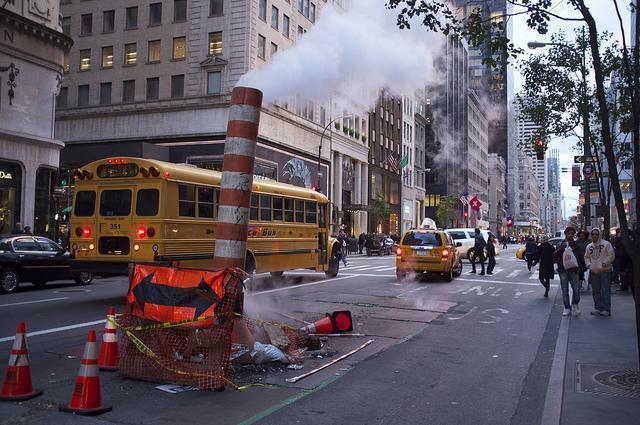How many striped cones are there?
Give a very brief answer. 4. How many cars are in the picture?
Give a very brief answer. 5. How many cars are there?
Give a very brief answer. 2. How many motorcycles are there?
Give a very brief answer. 0. 